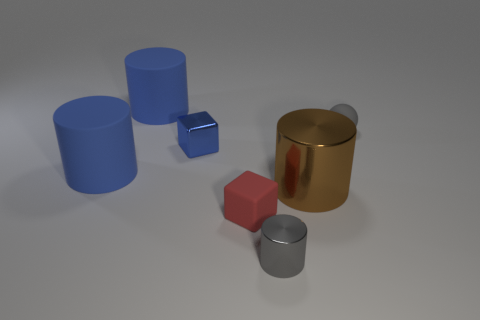There is a ball; does it have the same color as the thing that is in front of the matte block?
Make the answer very short. Yes. Are there any other big brown cylinders made of the same material as the brown cylinder?
Make the answer very short. No. How many large rubber objects are there?
Your answer should be very brief. 2. What is the material of the blue object that is on the right side of the big blue rubber thing behind the small metal block?
Give a very brief answer. Metal. What is the color of the cube that is the same material as the big brown cylinder?
Ensure brevity in your answer.  Blue. What is the shape of the object that is the same color as the small cylinder?
Keep it short and to the point. Sphere. There is a gray thing behind the tiny gray shiny object; does it have the same size as the block to the left of the small rubber block?
Offer a terse response. Yes. How many balls are metal things or small blue metal objects?
Provide a short and direct response. 0. Are the cube to the left of the small matte block and the gray cylinder made of the same material?
Your response must be concise. Yes. How many other things are the same size as the sphere?
Your answer should be compact. 3. 